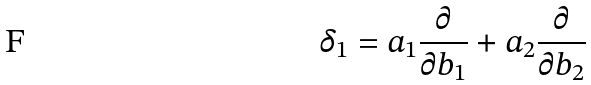<formula> <loc_0><loc_0><loc_500><loc_500>\delta _ { 1 } = a _ { 1 } \frac { \partial } { \partial b _ { 1 } } + a _ { 2 } \frac { \partial } { \partial b _ { 2 } }</formula> 